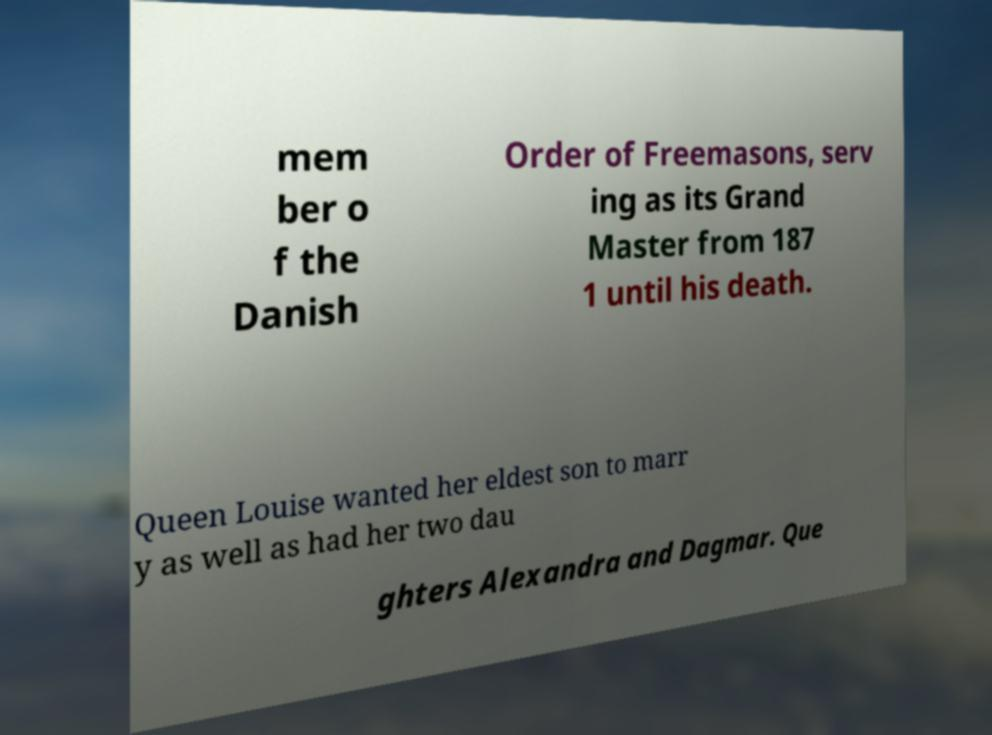Could you extract and type out the text from this image? mem ber o f the Danish Order of Freemasons, serv ing as its Grand Master from 187 1 until his death. Queen Louise wanted her eldest son to marr y as well as had her two dau ghters Alexandra and Dagmar. Que 